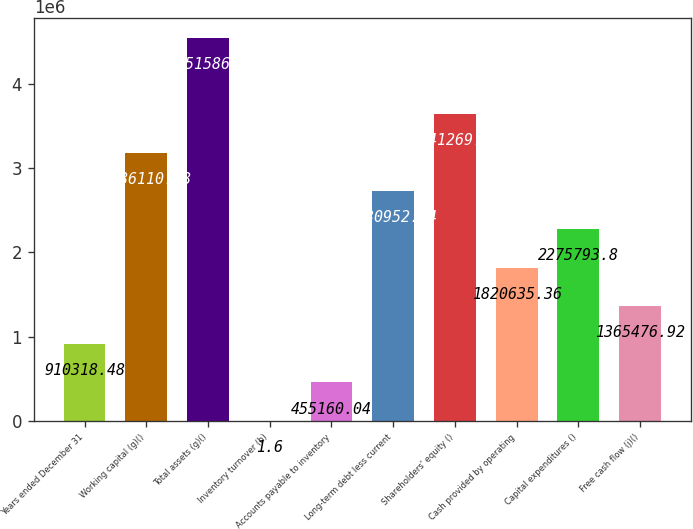Convert chart to OTSL. <chart><loc_0><loc_0><loc_500><loc_500><bar_chart><fcel>Years ended December 31<fcel>Working capital (g)()<fcel>Total assets (g)()<fcel>Inventory turnover (h)<fcel>Accounts payable to inventory<fcel>Long-term debt less current<fcel>Shareholders' equity ()<fcel>Cash provided by operating<fcel>Capital expenditures ()<fcel>Free cash flow (j)()<nl><fcel>910318<fcel>3.18611e+06<fcel>4.55159e+06<fcel>1.6<fcel>455160<fcel>2.73095e+06<fcel>3.64127e+06<fcel>1.82064e+06<fcel>2.27579e+06<fcel>1.36548e+06<nl></chart> 